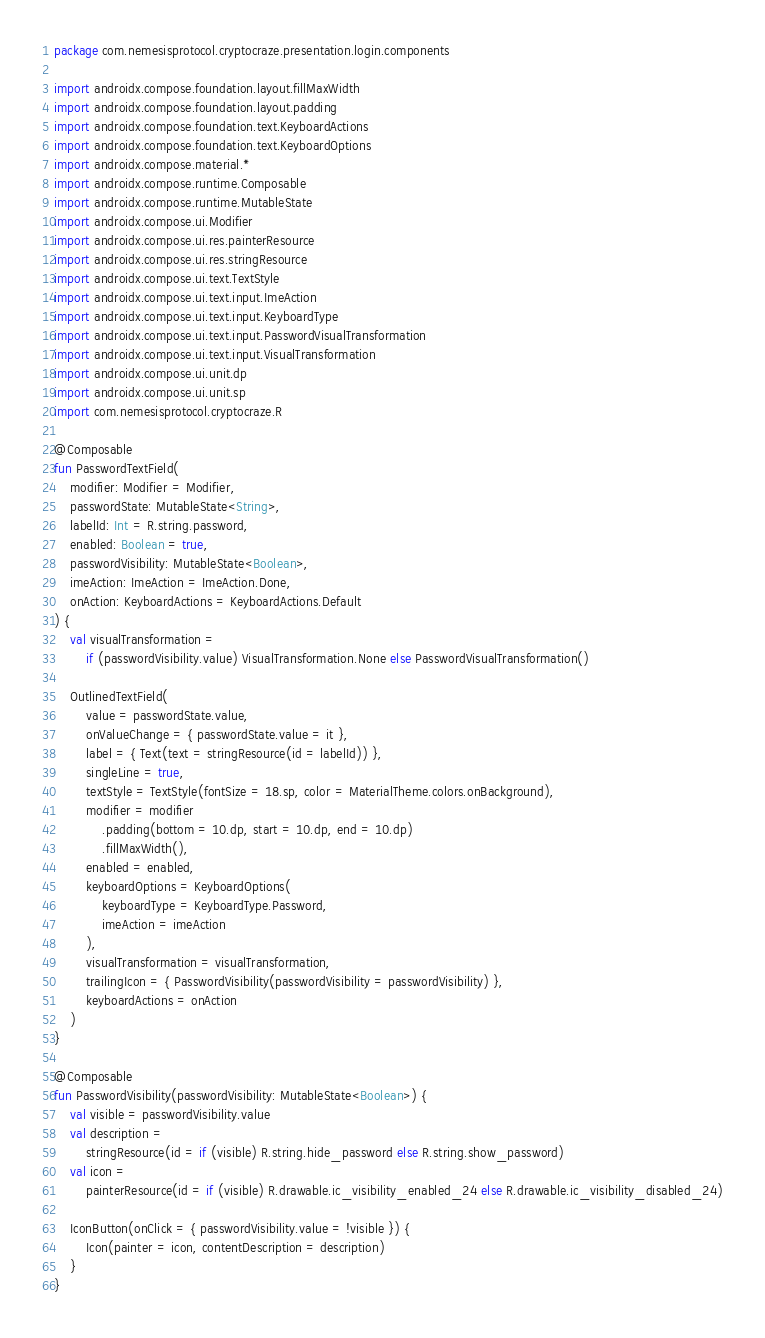Convert code to text. <code><loc_0><loc_0><loc_500><loc_500><_Kotlin_>package com.nemesisprotocol.cryptocraze.presentation.login.components

import androidx.compose.foundation.layout.fillMaxWidth
import androidx.compose.foundation.layout.padding
import androidx.compose.foundation.text.KeyboardActions
import androidx.compose.foundation.text.KeyboardOptions
import androidx.compose.material.*
import androidx.compose.runtime.Composable
import androidx.compose.runtime.MutableState
import androidx.compose.ui.Modifier
import androidx.compose.ui.res.painterResource
import androidx.compose.ui.res.stringResource
import androidx.compose.ui.text.TextStyle
import androidx.compose.ui.text.input.ImeAction
import androidx.compose.ui.text.input.KeyboardType
import androidx.compose.ui.text.input.PasswordVisualTransformation
import androidx.compose.ui.text.input.VisualTransformation
import androidx.compose.ui.unit.dp
import androidx.compose.ui.unit.sp
import com.nemesisprotocol.cryptocraze.R

@Composable
fun PasswordTextField(
    modifier: Modifier = Modifier,
    passwordState: MutableState<String>,
    labelId: Int = R.string.password,
    enabled: Boolean = true,
    passwordVisibility: MutableState<Boolean>,
    imeAction: ImeAction = ImeAction.Done,
    onAction: KeyboardActions = KeyboardActions.Default
) {
    val visualTransformation =
        if (passwordVisibility.value) VisualTransformation.None else PasswordVisualTransformation()

    OutlinedTextField(
        value = passwordState.value,
        onValueChange = { passwordState.value = it },
        label = { Text(text = stringResource(id = labelId)) },
        singleLine = true,
        textStyle = TextStyle(fontSize = 18.sp, color = MaterialTheme.colors.onBackground),
        modifier = modifier
            .padding(bottom = 10.dp, start = 10.dp, end = 10.dp)
            .fillMaxWidth(),
        enabled = enabled,
        keyboardOptions = KeyboardOptions(
            keyboardType = KeyboardType.Password,
            imeAction = imeAction
        ),
        visualTransformation = visualTransformation,
        trailingIcon = { PasswordVisibility(passwordVisibility = passwordVisibility) },
        keyboardActions = onAction
    )
}

@Composable
fun PasswordVisibility(passwordVisibility: MutableState<Boolean>) {
    val visible = passwordVisibility.value
    val description =
        stringResource(id = if (visible) R.string.hide_password else R.string.show_password)
    val icon =
        painterResource(id = if (visible) R.drawable.ic_visibility_enabled_24 else R.drawable.ic_visibility_disabled_24)

    IconButton(onClick = { passwordVisibility.value = !visible }) {
        Icon(painter = icon, contentDescription = description)
    }
}
</code> 